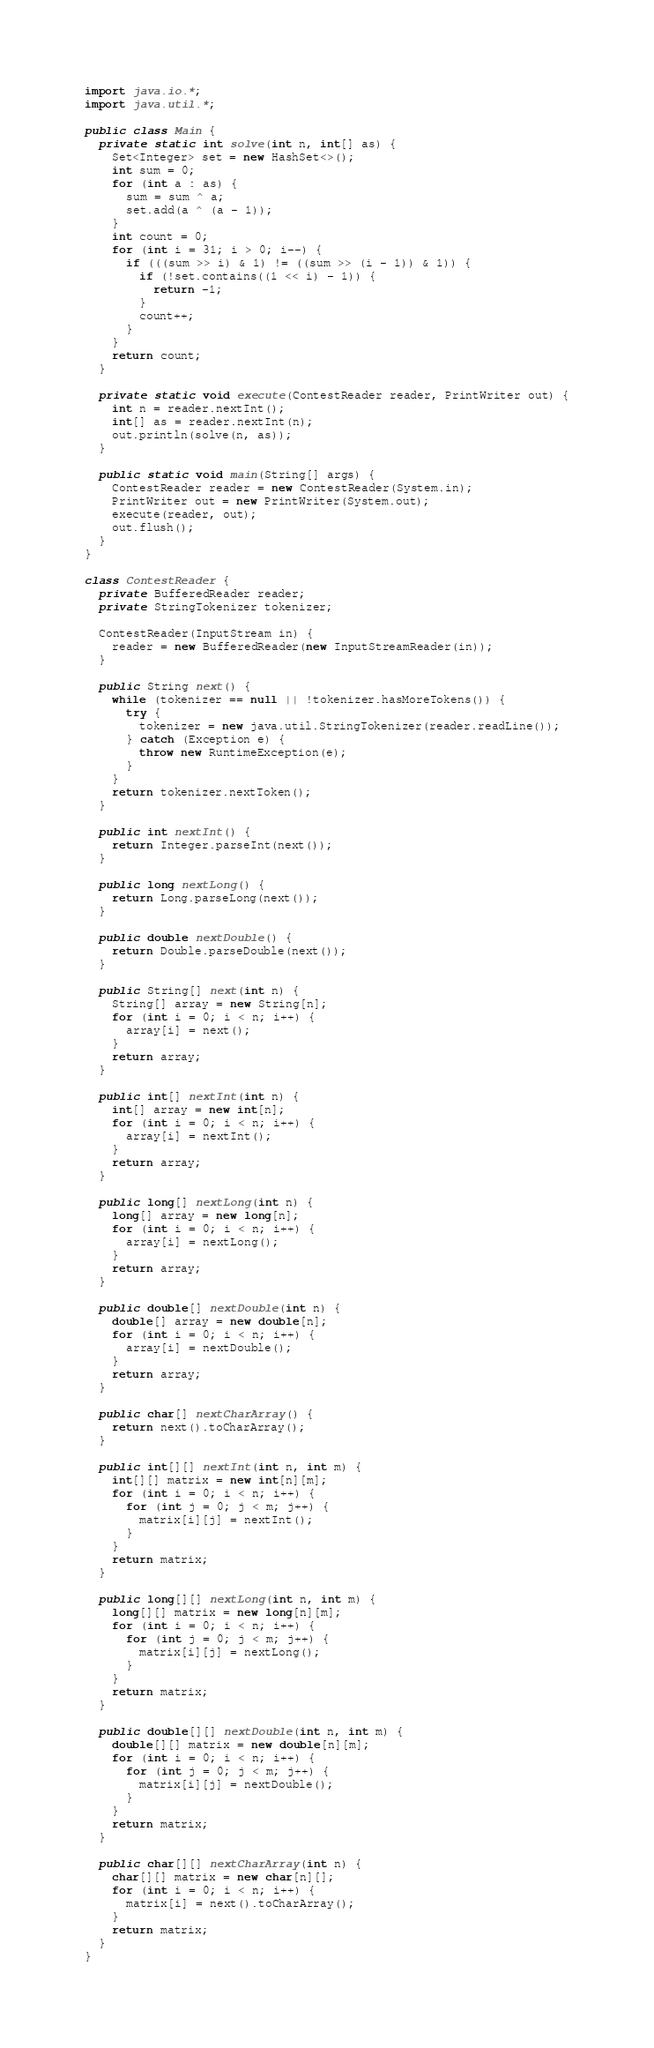Convert code to text. <code><loc_0><loc_0><loc_500><loc_500><_Java_>import java.io.*;
import java.util.*;

public class Main {
  private static int solve(int n, int[] as) {
    Set<Integer> set = new HashSet<>();
    int sum = 0;
    for (int a : as) {
      sum = sum ^ a;
      set.add(a ^ (a - 1));
    }
    int count = 0;
    for (int i = 31; i > 0; i--) {
      if (((sum >> i) & 1) != ((sum >> (i - 1)) & 1)) {
        if (!set.contains((1 << i) - 1)) {
          return -1;
        }
        count++;
      }
    }
    return count;
  }
  
  private static void execute(ContestReader reader, PrintWriter out) {
    int n = reader.nextInt();
    int[] as = reader.nextInt(n);
    out.println(solve(n, as));
  }
  
  public static void main(String[] args) {
    ContestReader reader = new ContestReader(System.in);
    PrintWriter out = new PrintWriter(System.out);
    execute(reader, out);
    out.flush();
  }
}

class ContestReader {
  private BufferedReader reader;
  private StringTokenizer tokenizer;
  
  ContestReader(InputStream in) {
    reader = new BufferedReader(new InputStreamReader(in));
  }
  
  public String next() {
    while (tokenizer == null || !tokenizer.hasMoreTokens()) {
      try {
        tokenizer = new java.util.StringTokenizer(reader.readLine());
      } catch (Exception e) {
        throw new RuntimeException(e);
      }
    }
    return tokenizer.nextToken();
  }
  
  public int nextInt() {
    return Integer.parseInt(next());
  }
  
  public long nextLong() {
    return Long.parseLong(next());
  }
  
  public double nextDouble() {
    return Double.parseDouble(next());
  }
  
  public String[] next(int n) {
    String[] array = new String[n];
    for (int i = 0; i < n; i++) {
      array[i] = next();
    }
    return array;
  }
  
  public int[] nextInt(int n) {
    int[] array = new int[n];
    for (int i = 0; i < n; i++) {
      array[i] = nextInt();
    }
    return array;
  }
  
  public long[] nextLong(int n) {
    long[] array = new long[n];
    for (int i = 0; i < n; i++) {
      array[i] = nextLong();
    }
    return array;
  }
  
  public double[] nextDouble(int n) {
    double[] array = new double[n];
    for (int i = 0; i < n; i++) {
      array[i] = nextDouble();
    }
    return array;
  }
  
  public char[] nextCharArray() {
    return next().toCharArray();
  }
  
  public int[][] nextInt(int n, int m) {
    int[][] matrix = new int[n][m];
    for (int i = 0; i < n; i++) {
      for (int j = 0; j < m; j++) {
        matrix[i][j] = nextInt();
      }
    }
    return matrix;
  }
  
  public long[][] nextLong(int n, int m) {
    long[][] matrix = new long[n][m];
    for (int i = 0; i < n; i++) {
      for (int j = 0; j < m; j++) {
        matrix[i][j] = nextLong();
      }
    }
    return matrix;
  }
  
  public double[][] nextDouble(int n, int m) {
    double[][] matrix = new double[n][m];
    for (int i = 0; i < n; i++) {
      for (int j = 0; j < m; j++) {
        matrix[i][j] = nextDouble();
      }
    }
    return matrix;
  }
  
  public char[][] nextCharArray(int n) {
    char[][] matrix = new char[n][];
    for (int i = 0; i < n; i++) {
      matrix[i] = next().toCharArray();
    }
    return matrix;
  }
}
</code> 